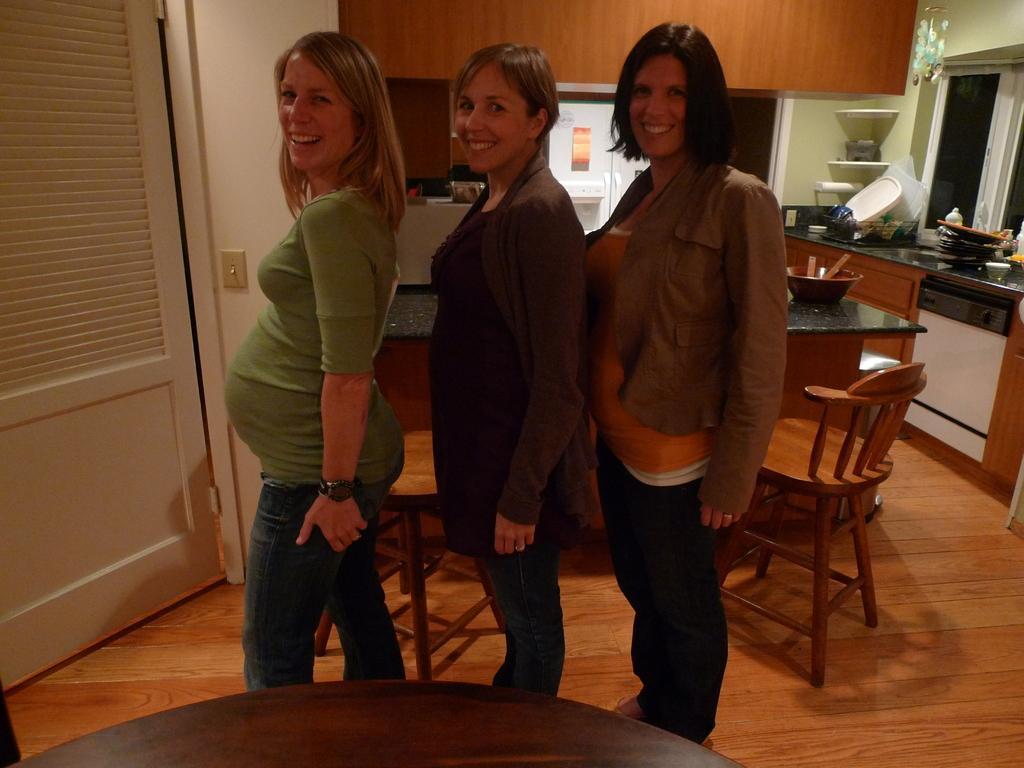Describe this image in one or two sentences. These 3 women are standing and holds a smile. In this room we can able to see chairs, table, furniture. On this furniture there are plates and things. On this table there is a bowl. 